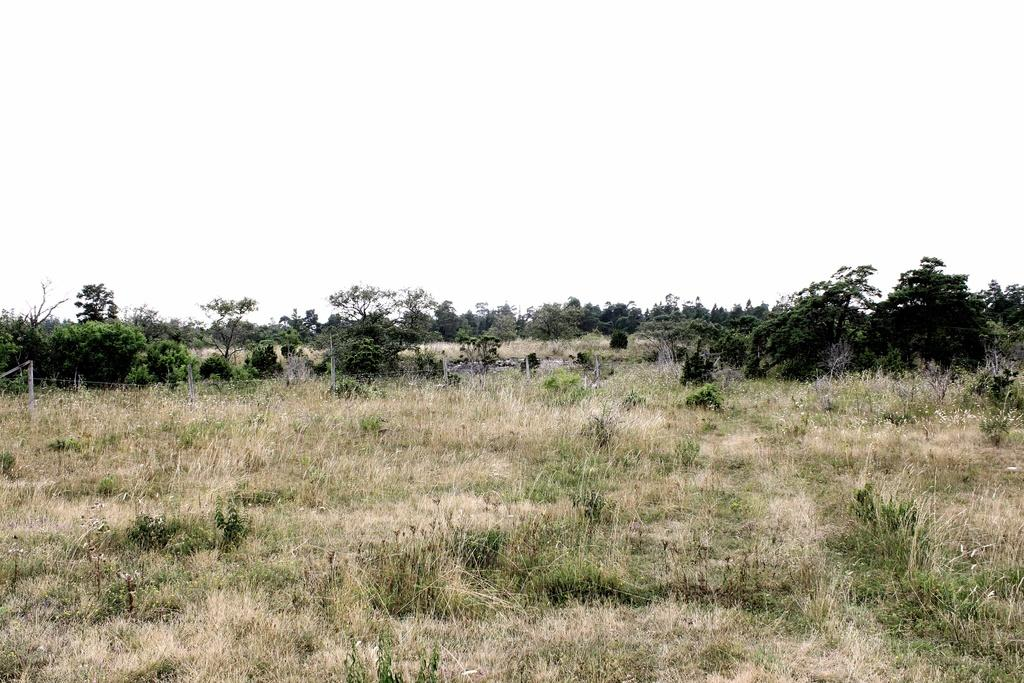What type of surface is visible in the image? There is a surface with grass plants in the image. What can be seen in the distance beyond the grass plants? There are plants and trees visible in the distance. What is visible in the background of the image? The sky is visible in the background of the image. How many beds are visible in the image? There are no beds present in the image. 